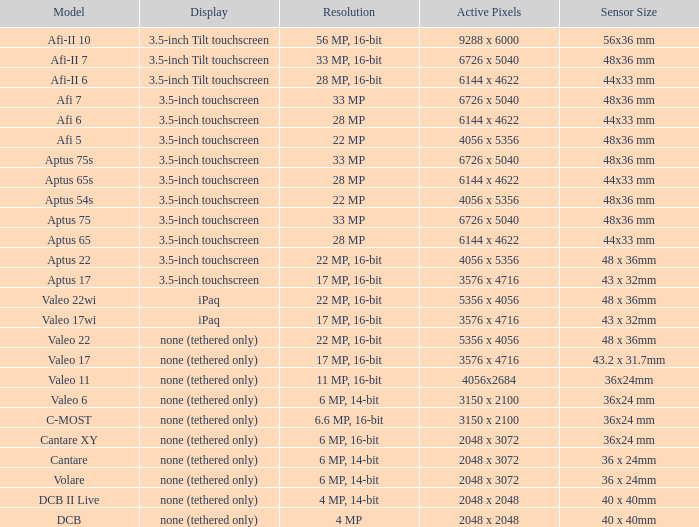What are the active pixels of the cantare model? 2048 x 3072. 